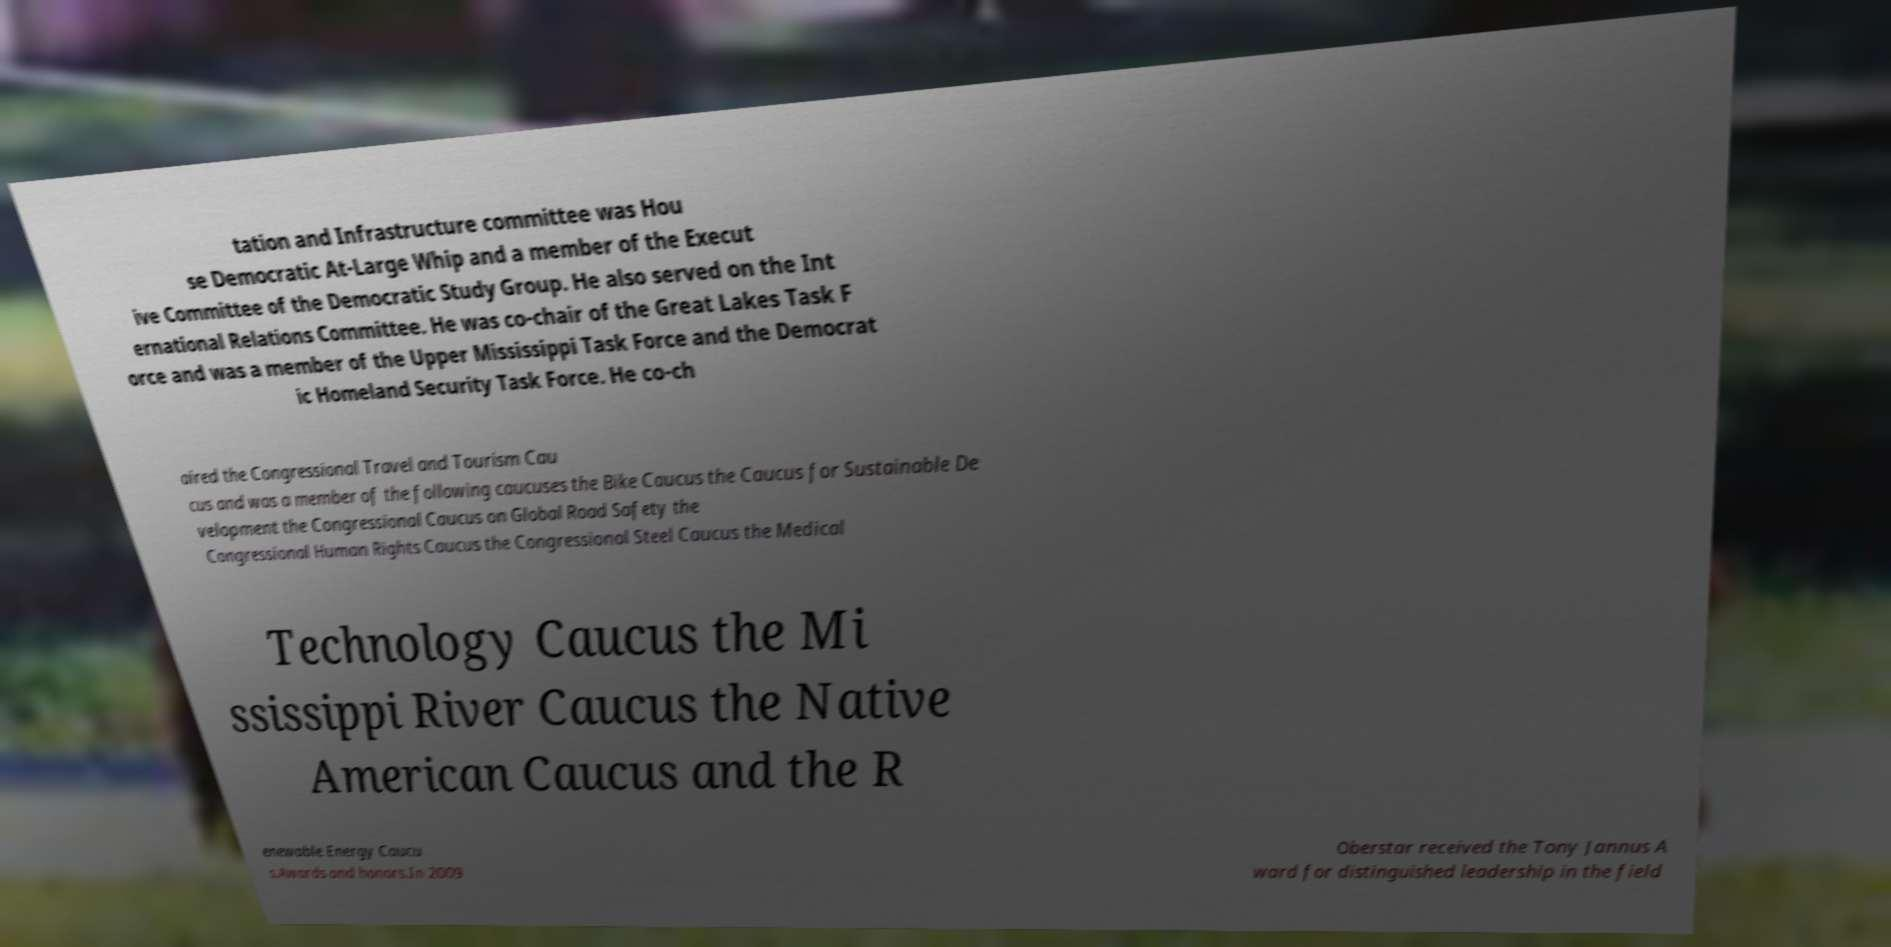Please identify and transcribe the text found in this image. tation and Infrastructure committee was Hou se Democratic At-Large Whip and a member of the Execut ive Committee of the Democratic Study Group. He also served on the Int ernational Relations Committee. He was co-chair of the Great Lakes Task F orce and was a member of the Upper Mississippi Task Force and the Democrat ic Homeland Security Task Force. He co-ch aired the Congressional Travel and Tourism Cau cus and was a member of the following caucuses the Bike Caucus the Caucus for Sustainable De velopment the Congressional Caucus on Global Road Safety the Congressional Human Rights Caucus the Congressional Steel Caucus the Medical Technology Caucus the Mi ssissippi River Caucus the Native American Caucus and the R enewable Energy Caucu s.Awards and honors.In 2009 Oberstar received the Tony Jannus A ward for distinguished leadership in the field 